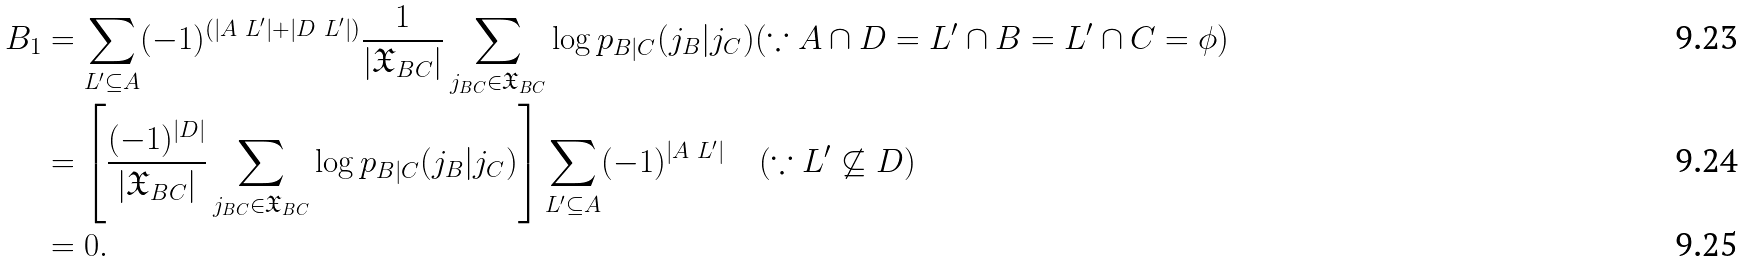Convert formula to latex. <formula><loc_0><loc_0><loc_500><loc_500>B _ { 1 } & = \sum _ { L ^ { \prime } \subseteq A } ( - 1 ) ^ { ( | A \ L ^ { \prime } | + | D \ L ^ { \prime } | ) } \frac { 1 } { | \mathfrak { X } _ { B C } | } \sum _ { j _ { B C } \in \mathfrak { X } _ { B C } } \log p _ { B | C } ( j _ { B } | j _ { C } ) ( \because A \cap D = L ^ { \prime } \cap B = L ^ { \prime } \cap C = \phi ) \\ & = \left [ \frac { ( - 1 ) ^ { | D | } } { | \mathfrak { X } _ { B C } | } \sum _ { j _ { B C } \in \mathfrak { X } _ { B C } } \log p _ { B | C } ( j _ { B } | j _ { C } ) \right ] \sum _ { L ^ { \prime } \subseteq A } ( - 1 ) ^ { | A \ L ^ { \prime } | } \quad ( \because L ^ { \prime } \not \subseteq D ) \\ & = 0 .</formula> 